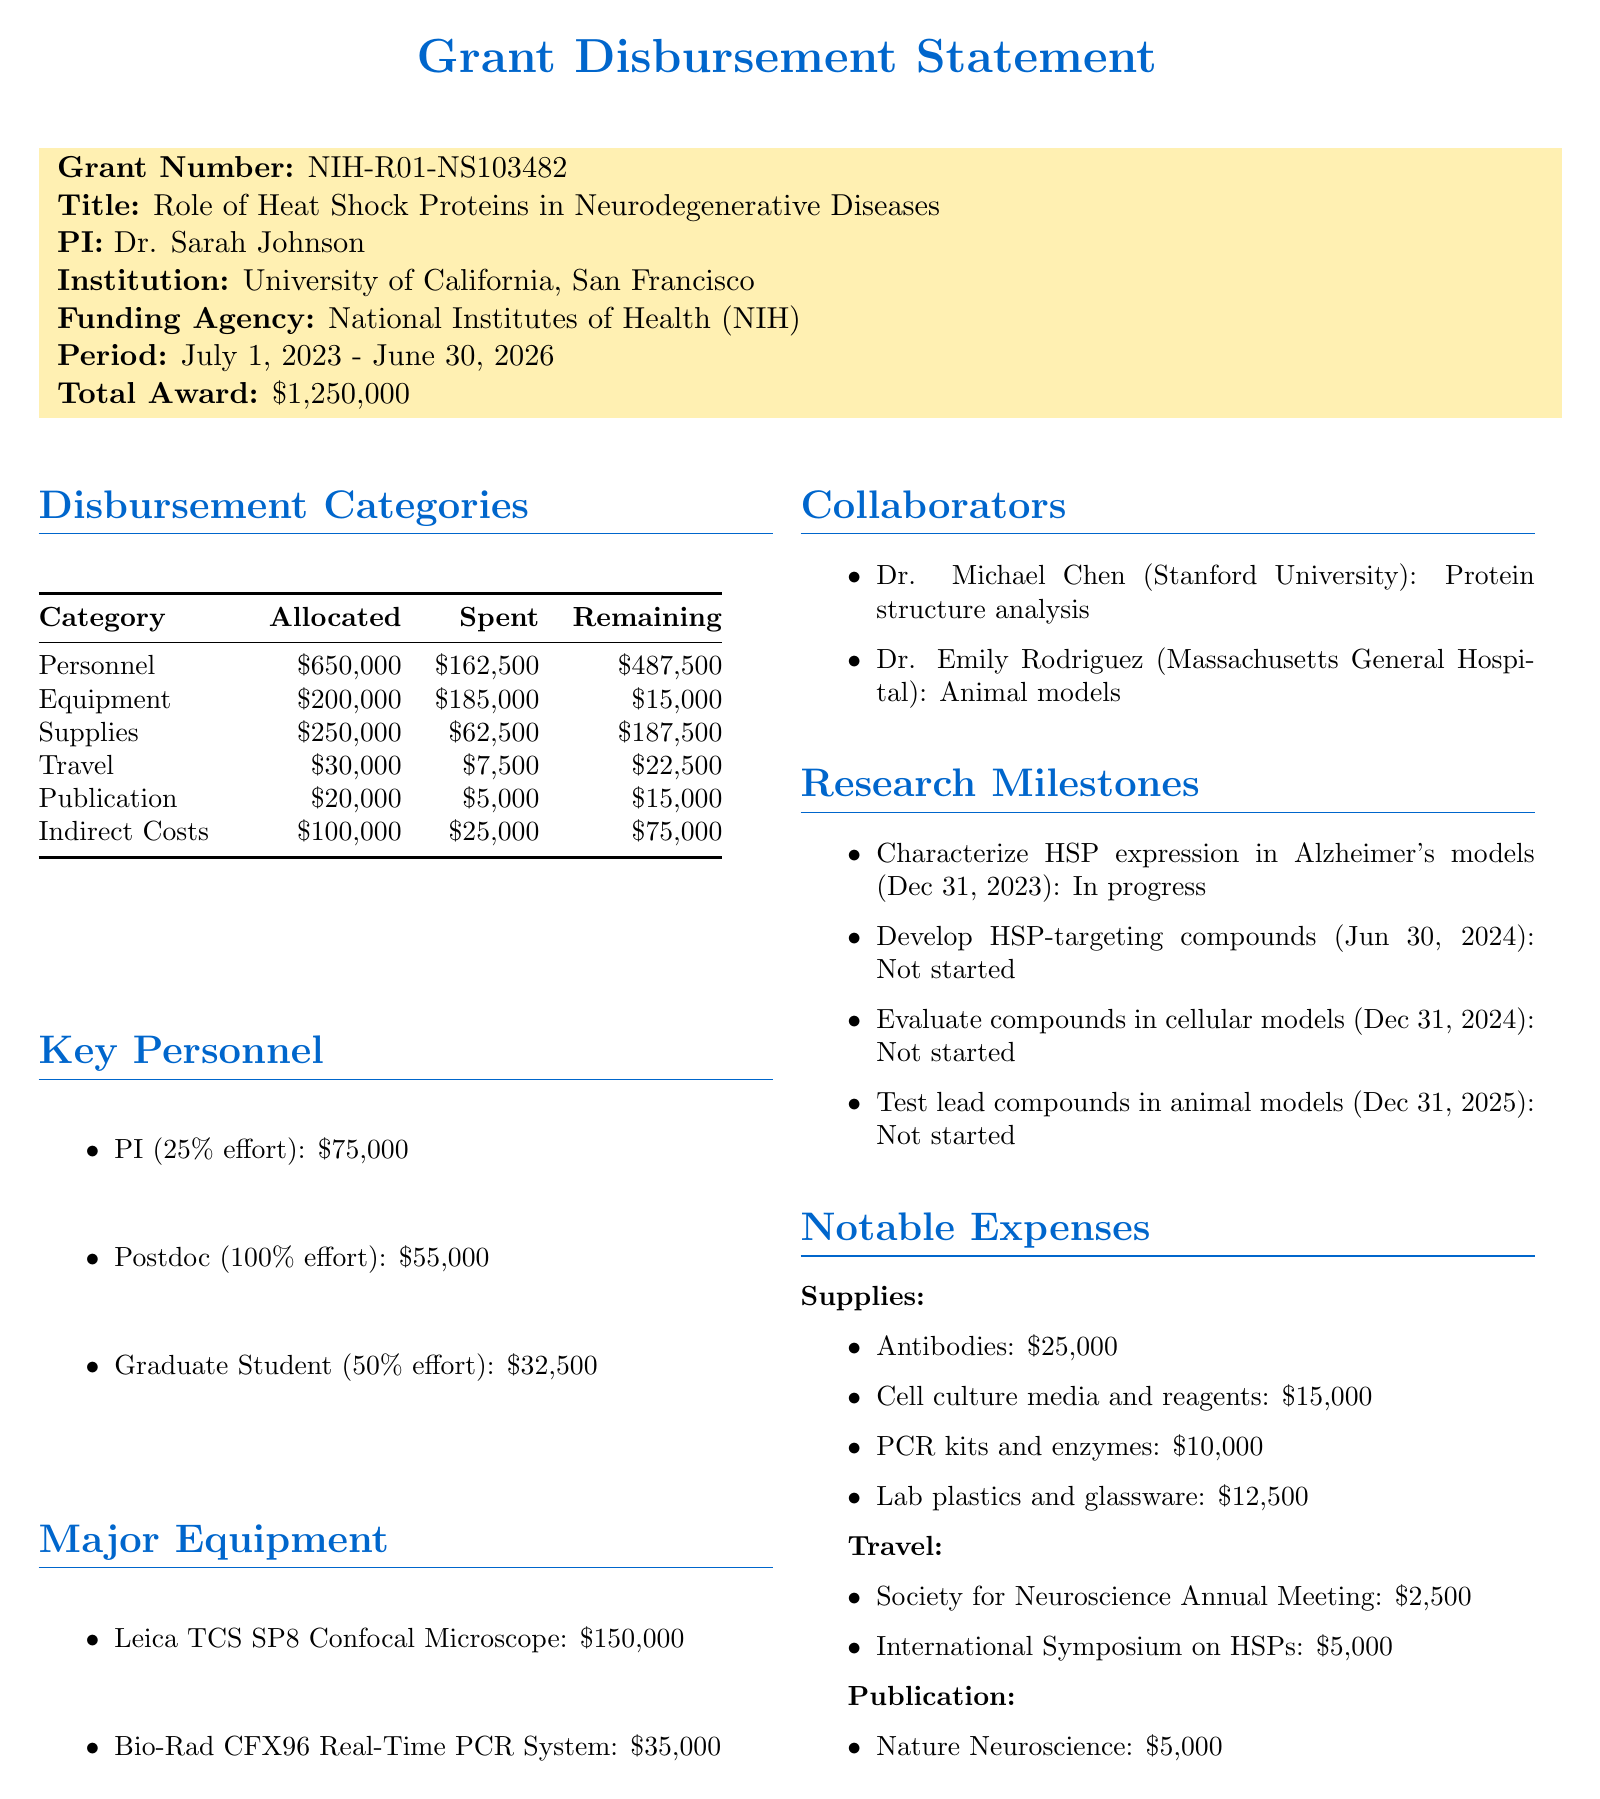What is the grant number? The grant number is specified in the document, which is NIH-R01-NS103482.
Answer: NIH-R01-NS103482 Who is the principal investigator? The principal investigator is listed in the document as Dr. Sarah Johnson.
Answer: Dr. Sarah Johnson What is the total award amount? The total award amount is explicitly stated in the document as $1,250,000.
Answer: $1,250,000 What is the allocated amount for personnel? The allocated amount for personnel is shown in the disbursement categories as $650,000.
Answer: $650,000 How much has been spent on equipment? The document details the amount spent on equipment, which is $185,000.
Answer: $185,000 What is the status of the milestone due on December 31, 2023? The document states that the status of the milestone due on December 31, 2023, is "In progress."
Answer: In progress How much is remaining in the travel category? The remaining amount for the travel category is provided in the document as $22,500.
Answer: $22,500 Which institution does Dr. Emily Rodriguez belong to? Dr. Emily Rodriguez's institution is specified in the document as Massachusetts General Hospital.
Answer: Massachusetts General Hospital What is the due date for the milestone "Develop novel HSP-targeting compounds"? The due date for this milestone is mentioned in the document as June 30, 2024.
Answer: June 30, 2024 